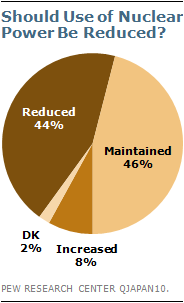Point out several critical features in this image. According to the respondents, 44% believe that the use of nuclear power should be reduced. The result of taking the sum of the two smallest segments and the difference between the two largest segments, dividing the larger value by the smaller value, when the input is 5... 